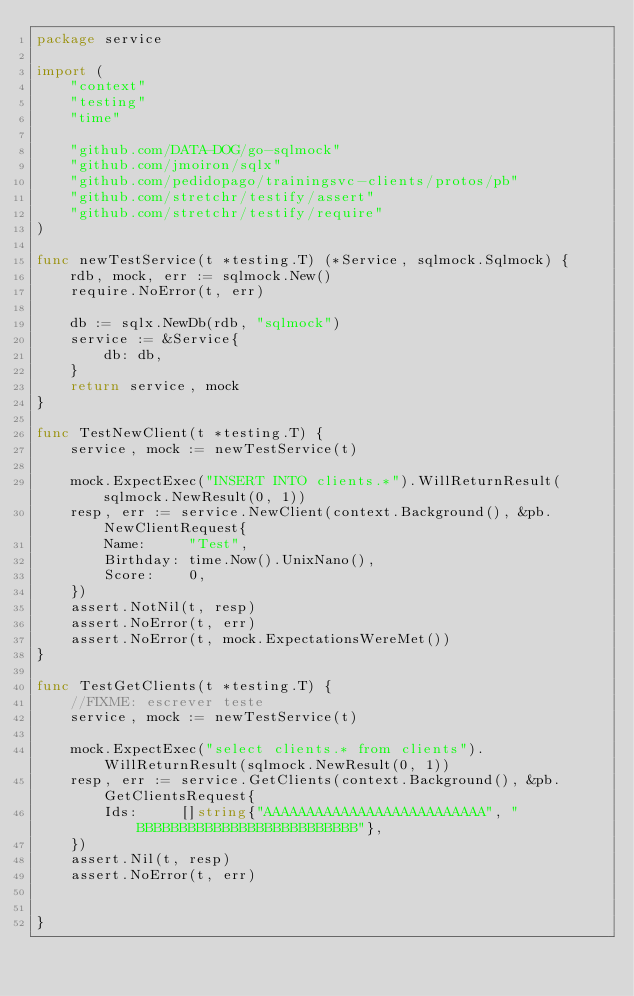<code> <loc_0><loc_0><loc_500><loc_500><_Go_>package service

import (
	"context"
	"testing"
	"time"

	"github.com/DATA-DOG/go-sqlmock"
	"github.com/jmoiron/sqlx"
	"github.com/pedidopago/trainingsvc-clients/protos/pb"
	"github.com/stretchr/testify/assert"
	"github.com/stretchr/testify/require"
)

func newTestService(t *testing.T) (*Service, sqlmock.Sqlmock) {
	rdb, mock, err := sqlmock.New()
	require.NoError(t, err)

	db := sqlx.NewDb(rdb, "sqlmock")
	service := &Service{
		db: db,
	}
	return service, mock
}

func TestNewClient(t *testing.T) {
	service, mock := newTestService(t)

	mock.ExpectExec("INSERT INTO clients.*").WillReturnResult(sqlmock.NewResult(0, 1))
	resp, err := service.NewClient(context.Background(), &pb.NewClientRequest{
		Name:     "Test",
		Birthday: time.Now().UnixNano(),
		Score:    0,
	})
	assert.NotNil(t, resp)
	assert.NoError(t, err)
	assert.NoError(t, mock.ExpectationsWereMet())
}

func TestGetClients(t *testing.T) {
	//FIXME: escrever teste
	service, mock := newTestService(t)

	mock.ExpectExec("select clients.* from clients").WillReturnResult(sqlmock.NewResult(0, 1))
	resp, err := service.GetClients(context.Background(), &pb.GetClientsRequest{
		Ids:     []string{"AAAAAAAAAAAAAAAAAAAAAAAAAA", "BBBBBBBBBBBBBBBBBBBBBBBBBB"},		
	})
	assert.Nil(t, resp)
	assert.NoError(t, err)
	
	
}
</code> 